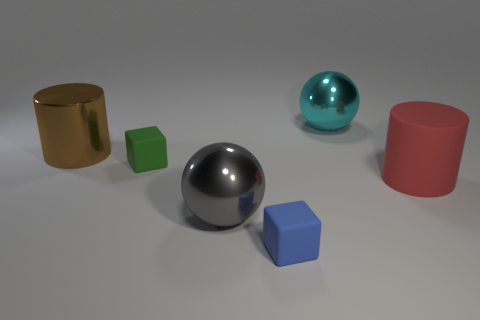Add 1 tiny green objects. How many objects exist? 7 Subtract all spheres. How many objects are left? 4 Subtract 0 purple spheres. How many objects are left? 6 Subtract all small rubber balls. Subtract all big cylinders. How many objects are left? 4 Add 2 big cyan metal things. How many big cyan metal things are left? 3 Add 4 big cyan things. How many big cyan things exist? 5 